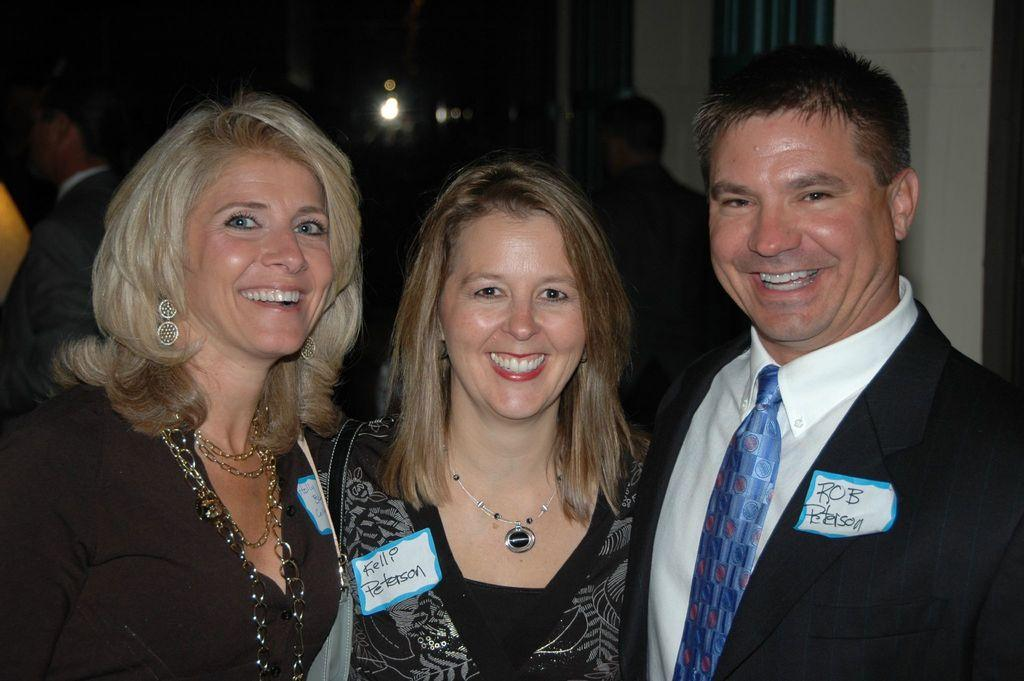How many people are present in the image? There are three people in the image: two women and one man. What expressions do the people have in the image? The women and the man are all smiling in the image. Can you describe the person visible in the background of the image? There is a person visible in the background of the image, but no specific details are provided. What can be seen in the image that indicates the presence of light? Light is visible in the image, but no specific details are provided about its source or intensity. What type of produce is being used as a reward for the man in the image? There is no produce or reward present in the image; it features two women and a man who are all smiling. What color is the umbrella being held by the person in the background of the image? There is no umbrella present in the image; it only features two women, a man, and a person in the background with no specific details provided. 